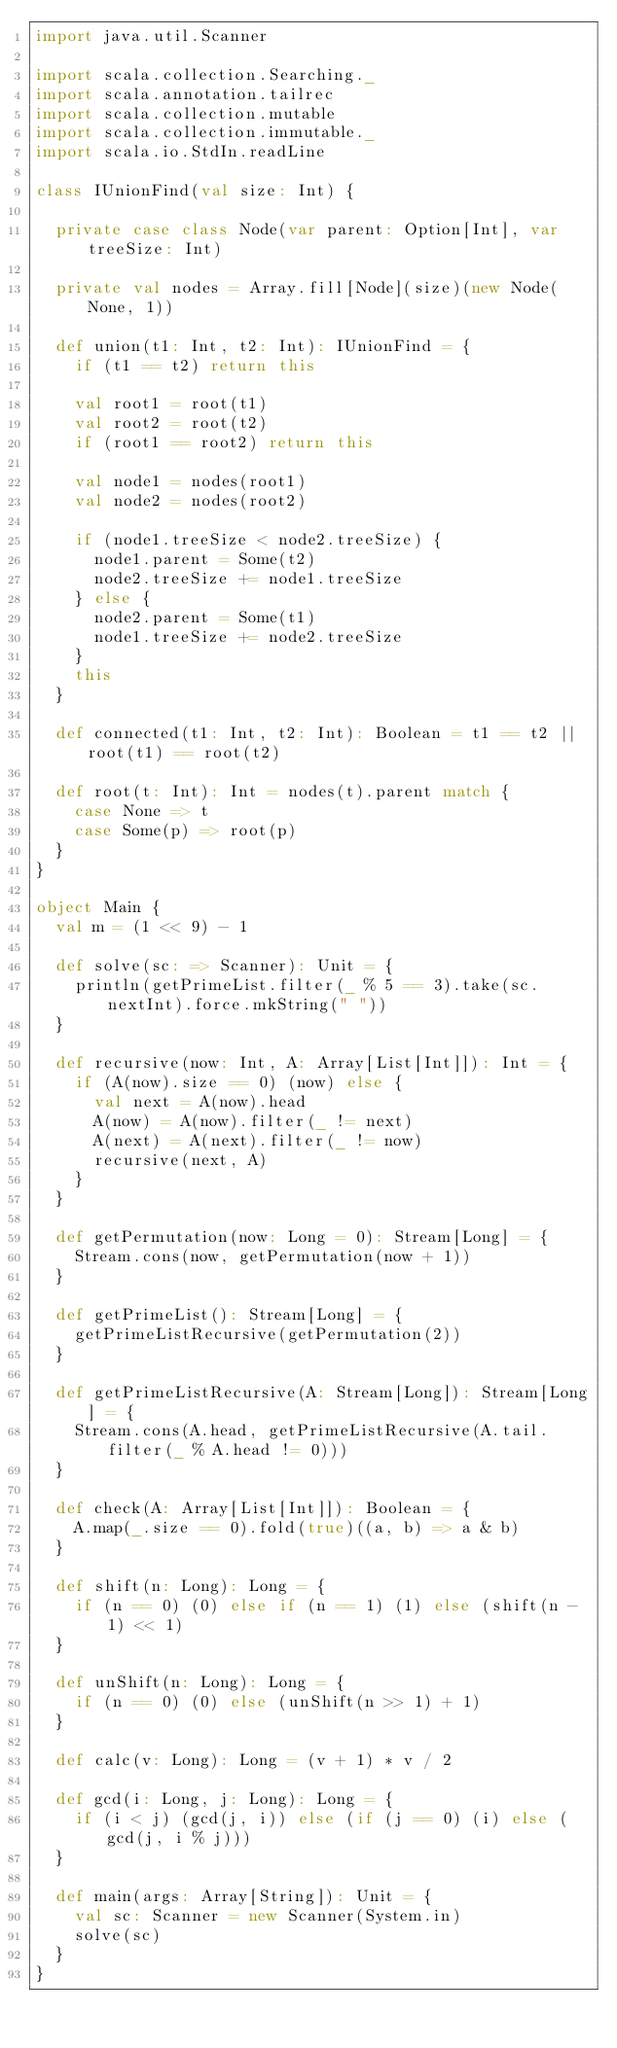Convert code to text. <code><loc_0><loc_0><loc_500><loc_500><_Scala_>import java.util.Scanner

import scala.collection.Searching._
import scala.annotation.tailrec
import scala.collection.mutable
import scala.collection.immutable._
import scala.io.StdIn.readLine

class IUnionFind(val size: Int) {

  private case class Node(var parent: Option[Int], var treeSize: Int)

  private val nodes = Array.fill[Node](size)(new Node(None, 1))

  def union(t1: Int, t2: Int): IUnionFind = {
    if (t1 == t2) return this

    val root1 = root(t1)
    val root2 = root(t2)
    if (root1 == root2) return this

    val node1 = nodes(root1)
    val node2 = nodes(root2)

    if (node1.treeSize < node2.treeSize) {
      node1.parent = Some(t2)
      node2.treeSize += node1.treeSize
    } else {
      node2.parent = Some(t1)
      node1.treeSize += node2.treeSize
    }
    this
  }

  def connected(t1: Int, t2: Int): Boolean = t1 == t2 || root(t1) == root(t2)

  def root(t: Int): Int = nodes(t).parent match {
    case None => t
    case Some(p) => root(p)
  }
}

object Main {
  val m = (1 << 9) - 1

  def solve(sc: => Scanner): Unit = {
    println(getPrimeList.filter(_ % 5 == 3).take(sc.nextInt).force.mkString(" "))
  }

  def recursive(now: Int, A: Array[List[Int]]): Int = {
    if (A(now).size == 0) (now) else {
      val next = A(now).head
      A(now) = A(now).filter(_ != next)
      A(next) = A(next).filter(_ != now)
      recursive(next, A)
    }
  }

  def getPermutation(now: Long = 0): Stream[Long] = {
    Stream.cons(now, getPermutation(now + 1))
  }

  def getPrimeList(): Stream[Long] = {
    getPrimeListRecursive(getPermutation(2))
  }

  def getPrimeListRecursive(A: Stream[Long]): Stream[Long] = {
    Stream.cons(A.head, getPrimeListRecursive(A.tail.filter(_ % A.head != 0)))
  }

  def check(A: Array[List[Int]]): Boolean = {
    A.map(_.size == 0).fold(true)((a, b) => a & b)
  }

  def shift(n: Long): Long = {
    if (n == 0) (0) else if (n == 1) (1) else (shift(n - 1) << 1)
  }

  def unShift(n: Long): Long = {
    if (n == 0) (0) else (unShift(n >> 1) + 1)
  }

  def calc(v: Long): Long = (v + 1) * v / 2

  def gcd(i: Long, j: Long): Long = {
    if (i < j) (gcd(j, i)) else (if (j == 0) (i) else (gcd(j, i % j)))
  }

  def main(args: Array[String]): Unit = {
    val sc: Scanner = new Scanner(System.in)
    solve(sc)
  }
}</code> 